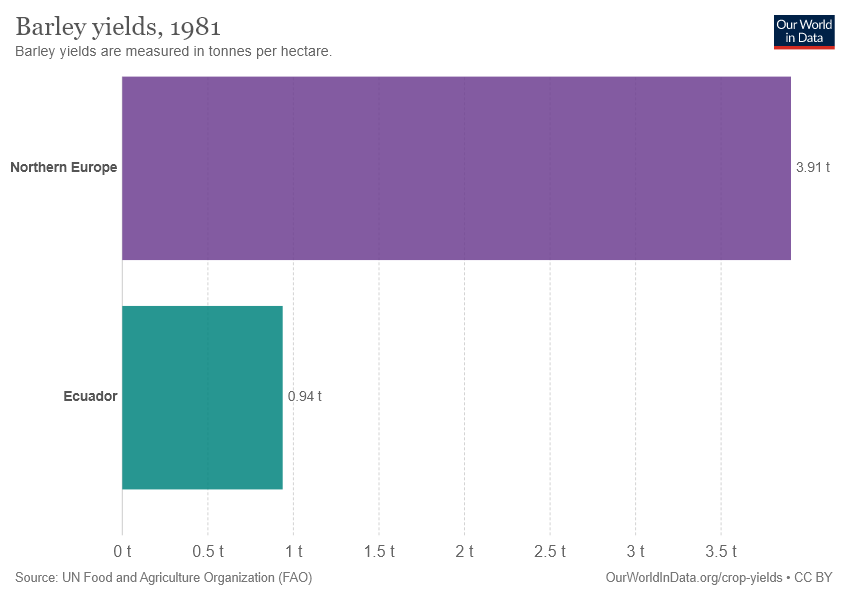Mention a couple of crucial points in this snapshot. The average of the two values is less than their difference. The country/region with a value of 3.91 t is Northern Europe. 